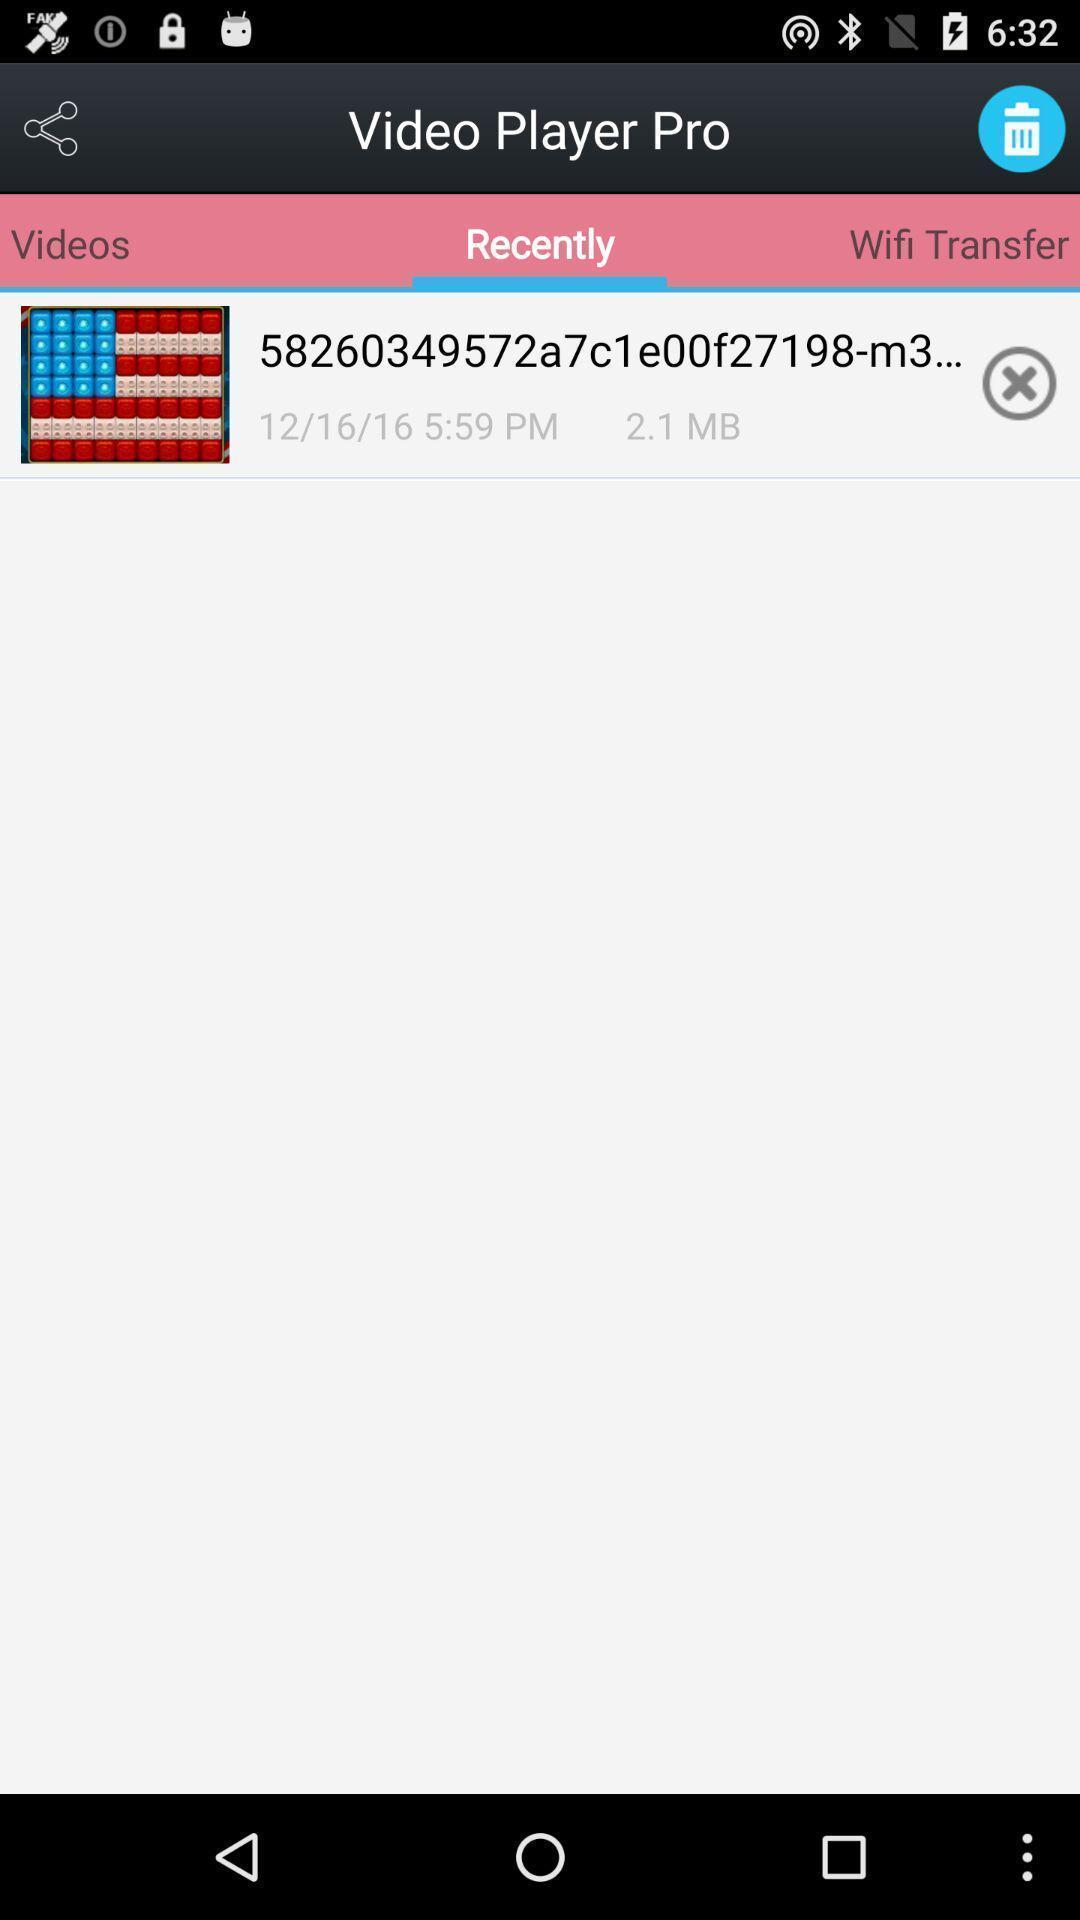Provide a textual representation of this image. Screen displaying the video in a recent folder. 